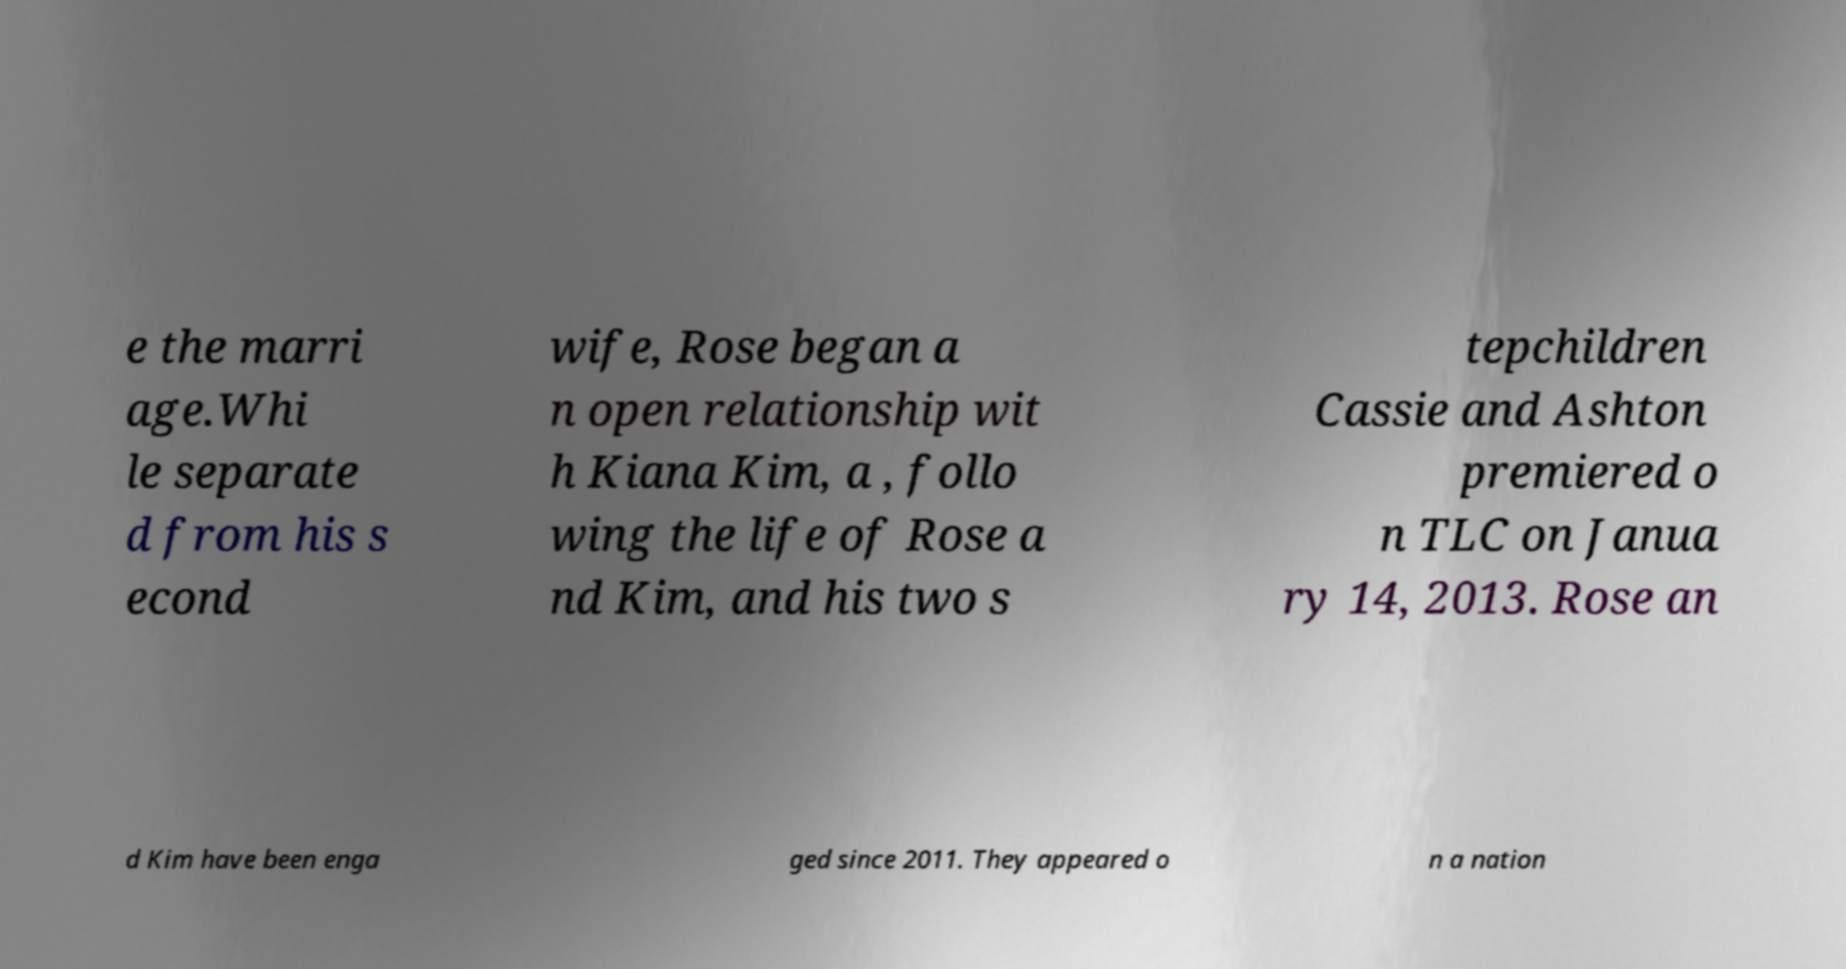Could you extract and type out the text from this image? e the marri age.Whi le separate d from his s econd wife, Rose began a n open relationship wit h Kiana Kim, a , follo wing the life of Rose a nd Kim, and his two s tepchildren Cassie and Ashton premiered o n TLC on Janua ry 14, 2013. Rose an d Kim have been enga ged since 2011. They appeared o n a nation 